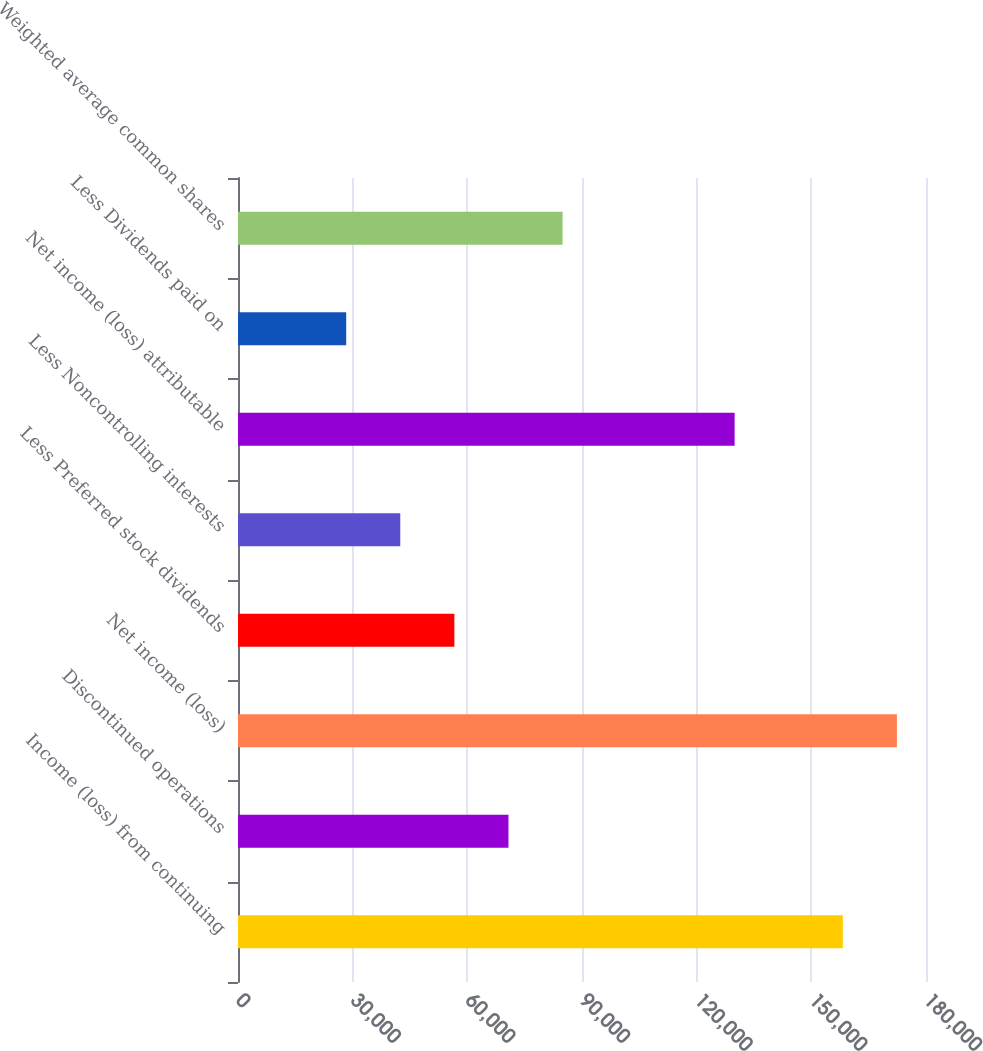<chart> <loc_0><loc_0><loc_500><loc_500><bar_chart><fcel>Income (loss) from continuing<fcel>Discontinued operations<fcel>Net income (loss)<fcel>Less Preferred stock dividends<fcel>Less Noncontrolling interests<fcel>Net income (loss) attributable<fcel>Less Dividends paid on<fcel>Weighted average common shares<nl><fcel>158236<fcel>70761.2<fcel>172388<fcel>56609.2<fcel>42457.2<fcel>129932<fcel>28305.3<fcel>84913.1<nl></chart> 